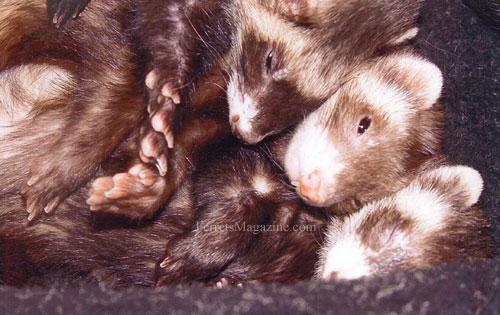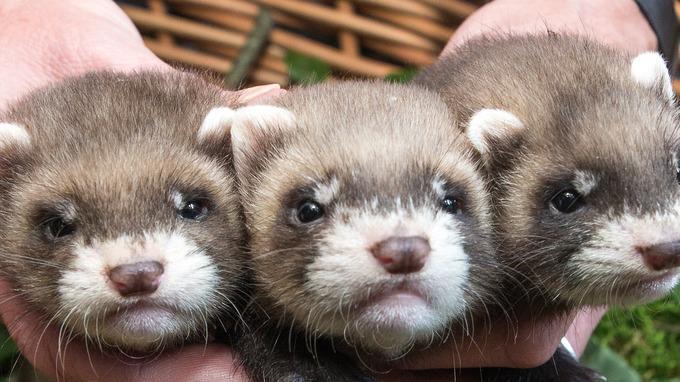The first image is the image on the left, the second image is the image on the right. Evaluate the accuracy of this statement regarding the images: "All images show ferrets with their faces aligned together, and at least one image contains exactly three ferrets.". Is it true? Answer yes or no. Yes. The first image is the image on the left, the second image is the image on the right. Considering the images on both sides, is "The animals in one of the images are near a window." valid? Answer yes or no. No. 